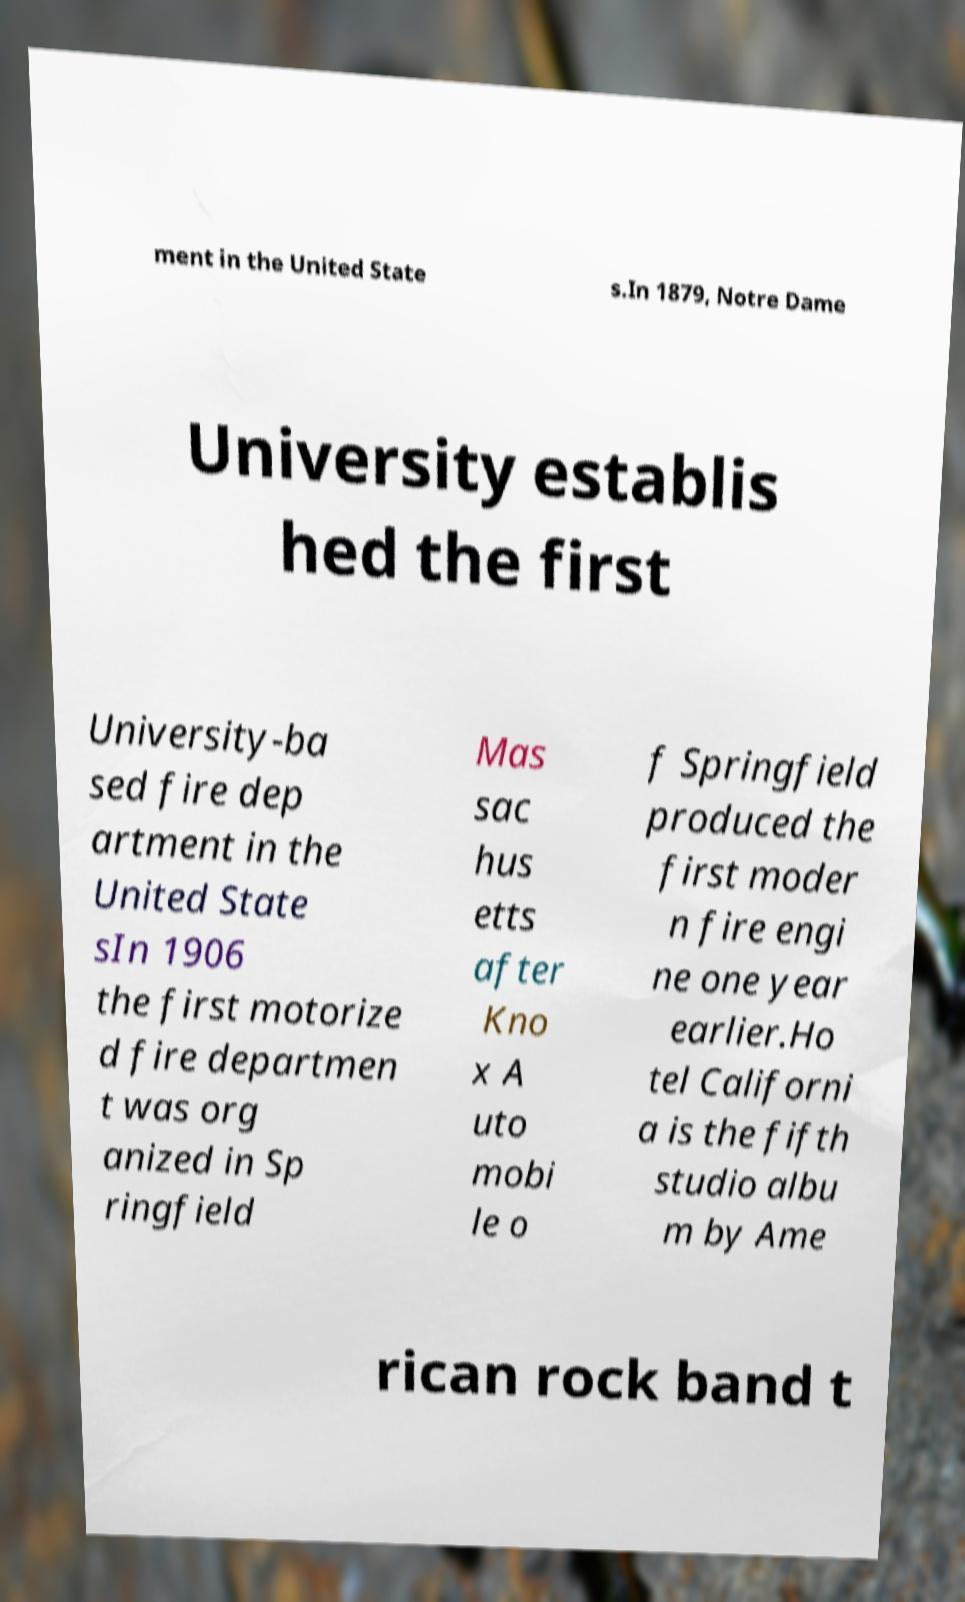Please identify and transcribe the text found in this image. ment in the United State s.In 1879, Notre Dame University establis hed the first University-ba sed fire dep artment in the United State sIn 1906 the first motorize d fire departmen t was org anized in Sp ringfield Mas sac hus etts after Kno x A uto mobi le o f Springfield produced the first moder n fire engi ne one year earlier.Ho tel Californi a is the fifth studio albu m by Ame rican rock band t 